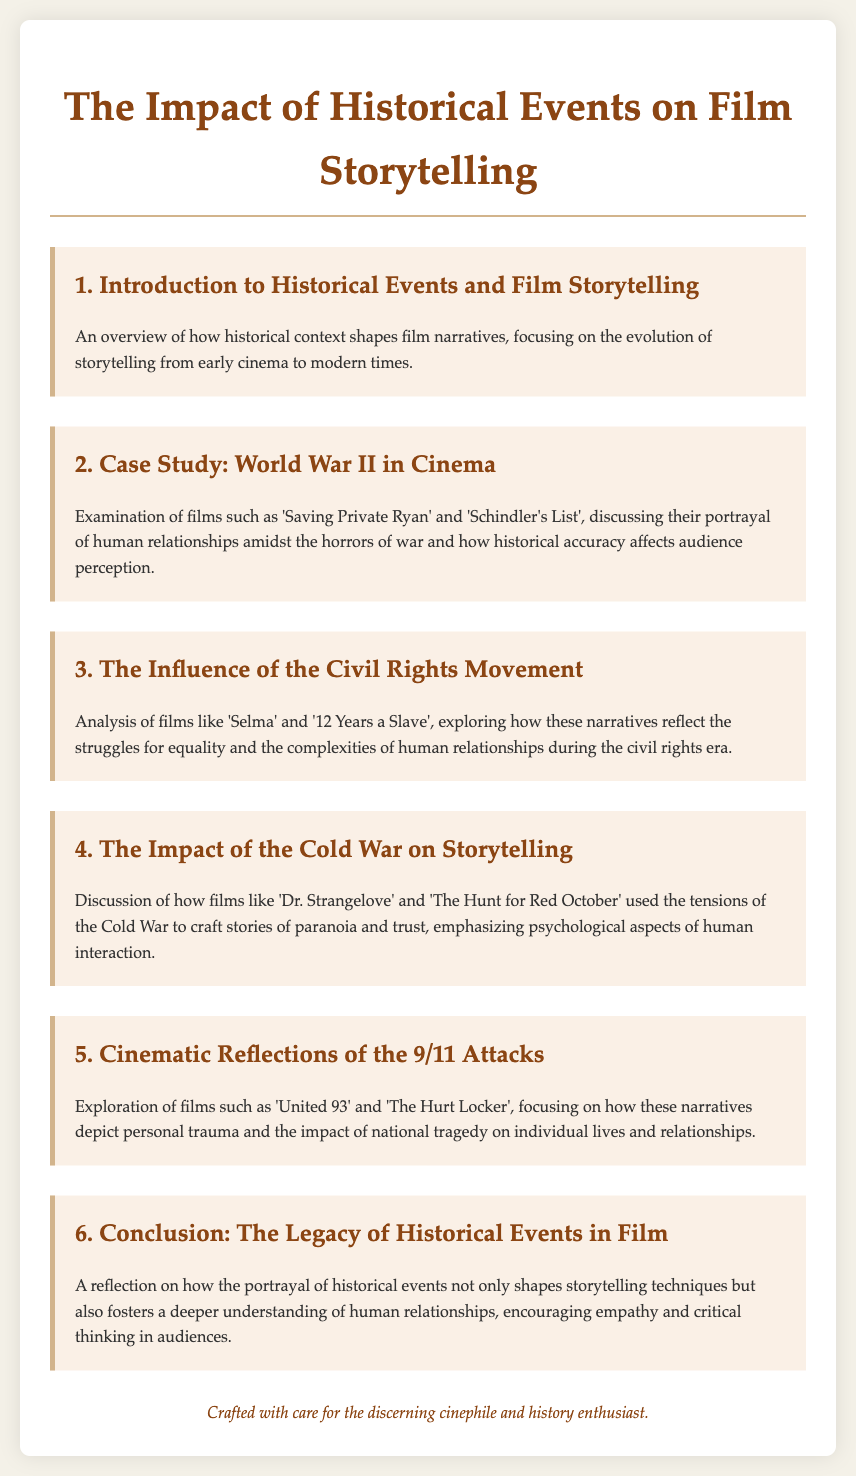What is the title of the document? The title of the document is presented at the top of the agenda, which is the central topic of the content.
Answer: The Impact of Historical Events on Film Storytelling How many main agenda items are there? The document outlines several agenda items, and the number of these items can be counted directly from the sections listed.
Answer: 6 Which film is mentioned as a case study for World War II? The document specifies certain films in the context of World War II and highlights one as a case study.
Answer: Saving Private Ryan What movement does the third agenda item focus on? The title of the third agenda item indicates which significant historical movement is being discussed.
Answer: Civil Rights Movement What aspect of human interaction is emphasized in the discussion about the Cold War? The document describes the psychological themes presented in films related to the Cold War era.
Answer: Paranoia and trust What does the conclusion reflect on regarding the legacy of historical events? The conclusion addresses the implications historical portrayals have on storytelling and audience understanding, specifically what it fosters.
Answer: Empathy and critical thinking Which film is used to explore the cinematic reflections of the 9/11 attacks? The document lists specific films that serve to illustrate the narrative surrounding the 9/11 attacks.
Answer: United 93 